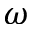Convert formula to latex. <formula><loc_0><loc_0><loc_500><loc_500>\omega</formula> 